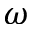Convert formula to latex. <formula><loc_0><loc_0><loc_500><loc_500>\omega</formula> 